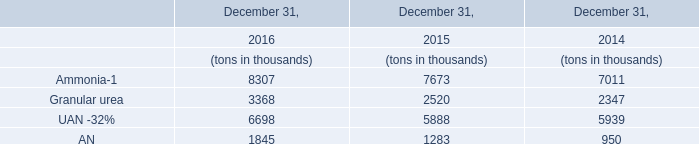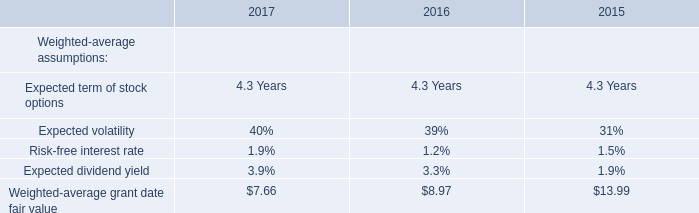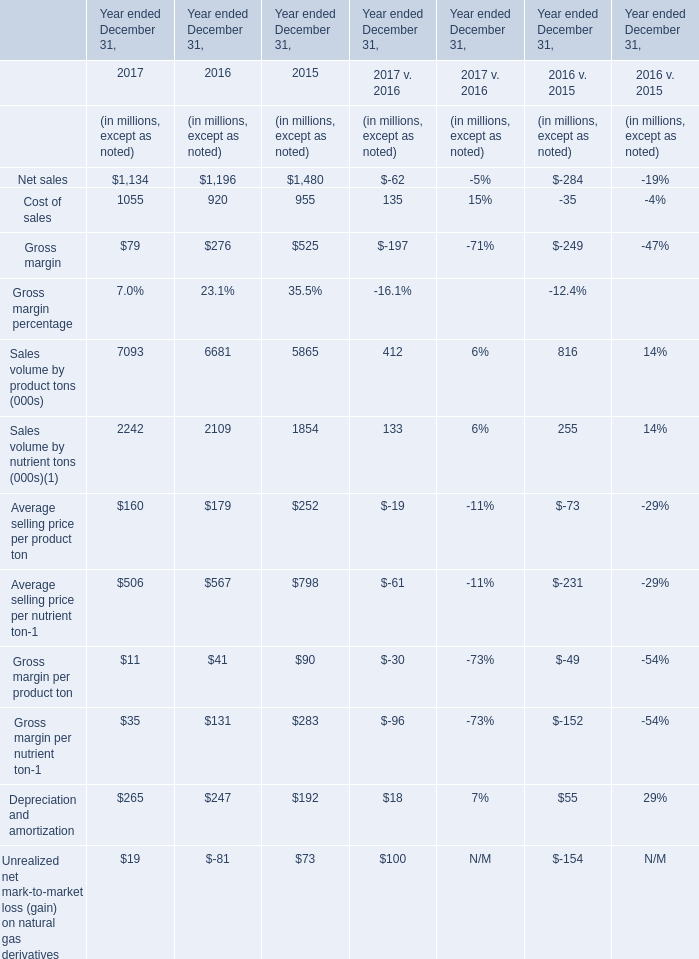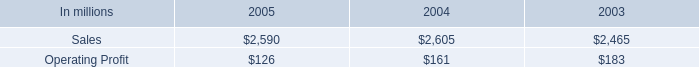was percentage of consumer packaging sales was due to foodservice net sales in 2005? 
Computations: (437 / 2590)
Answer: 0.16873. 